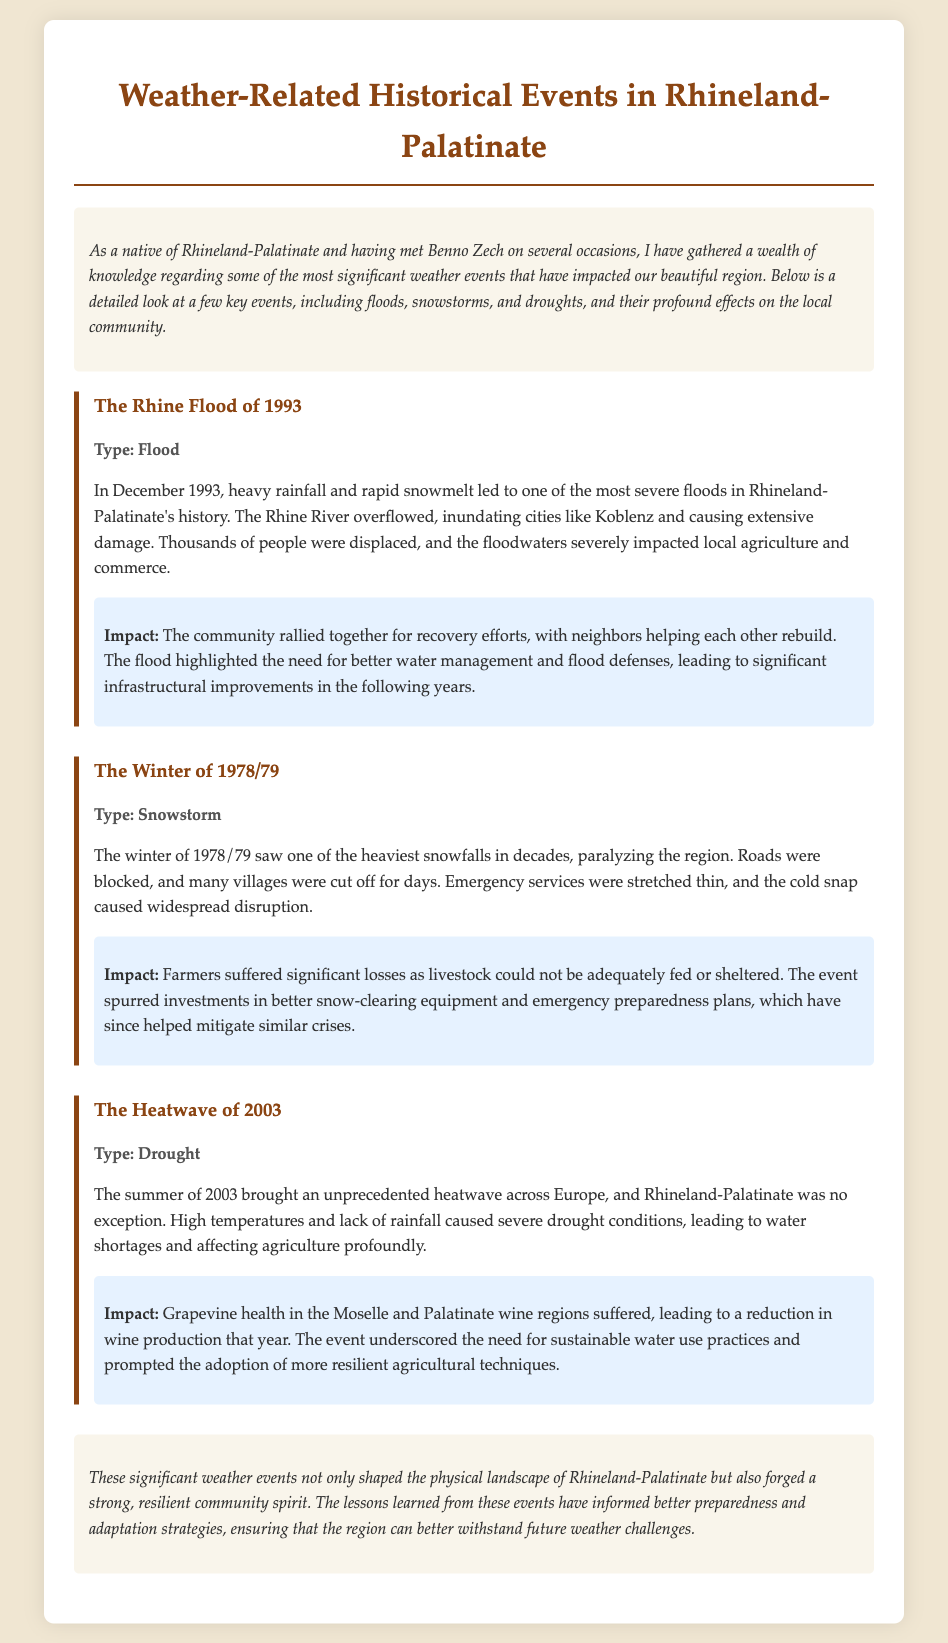What was the date of the Rhine Flood? The document specifies that the flood occurred in December 1993.
Answer: December 1993 What type of disaster was the event in Winter of 1978/79? The document categorizes this event as a snowstorm.
Answer: Snowstorm Which river overflowed during the 1993 flood? The document states that the Rhine River overflowed.
Answer: Rhine River What severe weather event took place in the summer of 2003? The document notes that a heatwave occurred during this time.
Answer: Heatwave What was the impact on the wine production in 2003? The document mentions that grapevine health suffered, leading to a reduction in wine production.
Answer: Reduction in wine production Why did the 1978/79 snowstorm prompt changes in local infrastructure? The event caused significant disruption, leading to investments in better snow-clearing equipment and emergency preparedness plans.
Answer: Investments in snow-clearing equipment What community response followed the Rhine Flood of 1993? According to the document, the community rallied together for recovery efforts.
Answer: Recovery efforts What were local agriculture and commerce affected by during the 1993 flood? The document indicates that the floodwaters severely impacted local agriculture and commerce.
Answer: Floodwaters What did the 2003 heatwave underscore the need for? The document states it underscored the need for sustainable water use practices.
Answer: Sustainable water use practices 